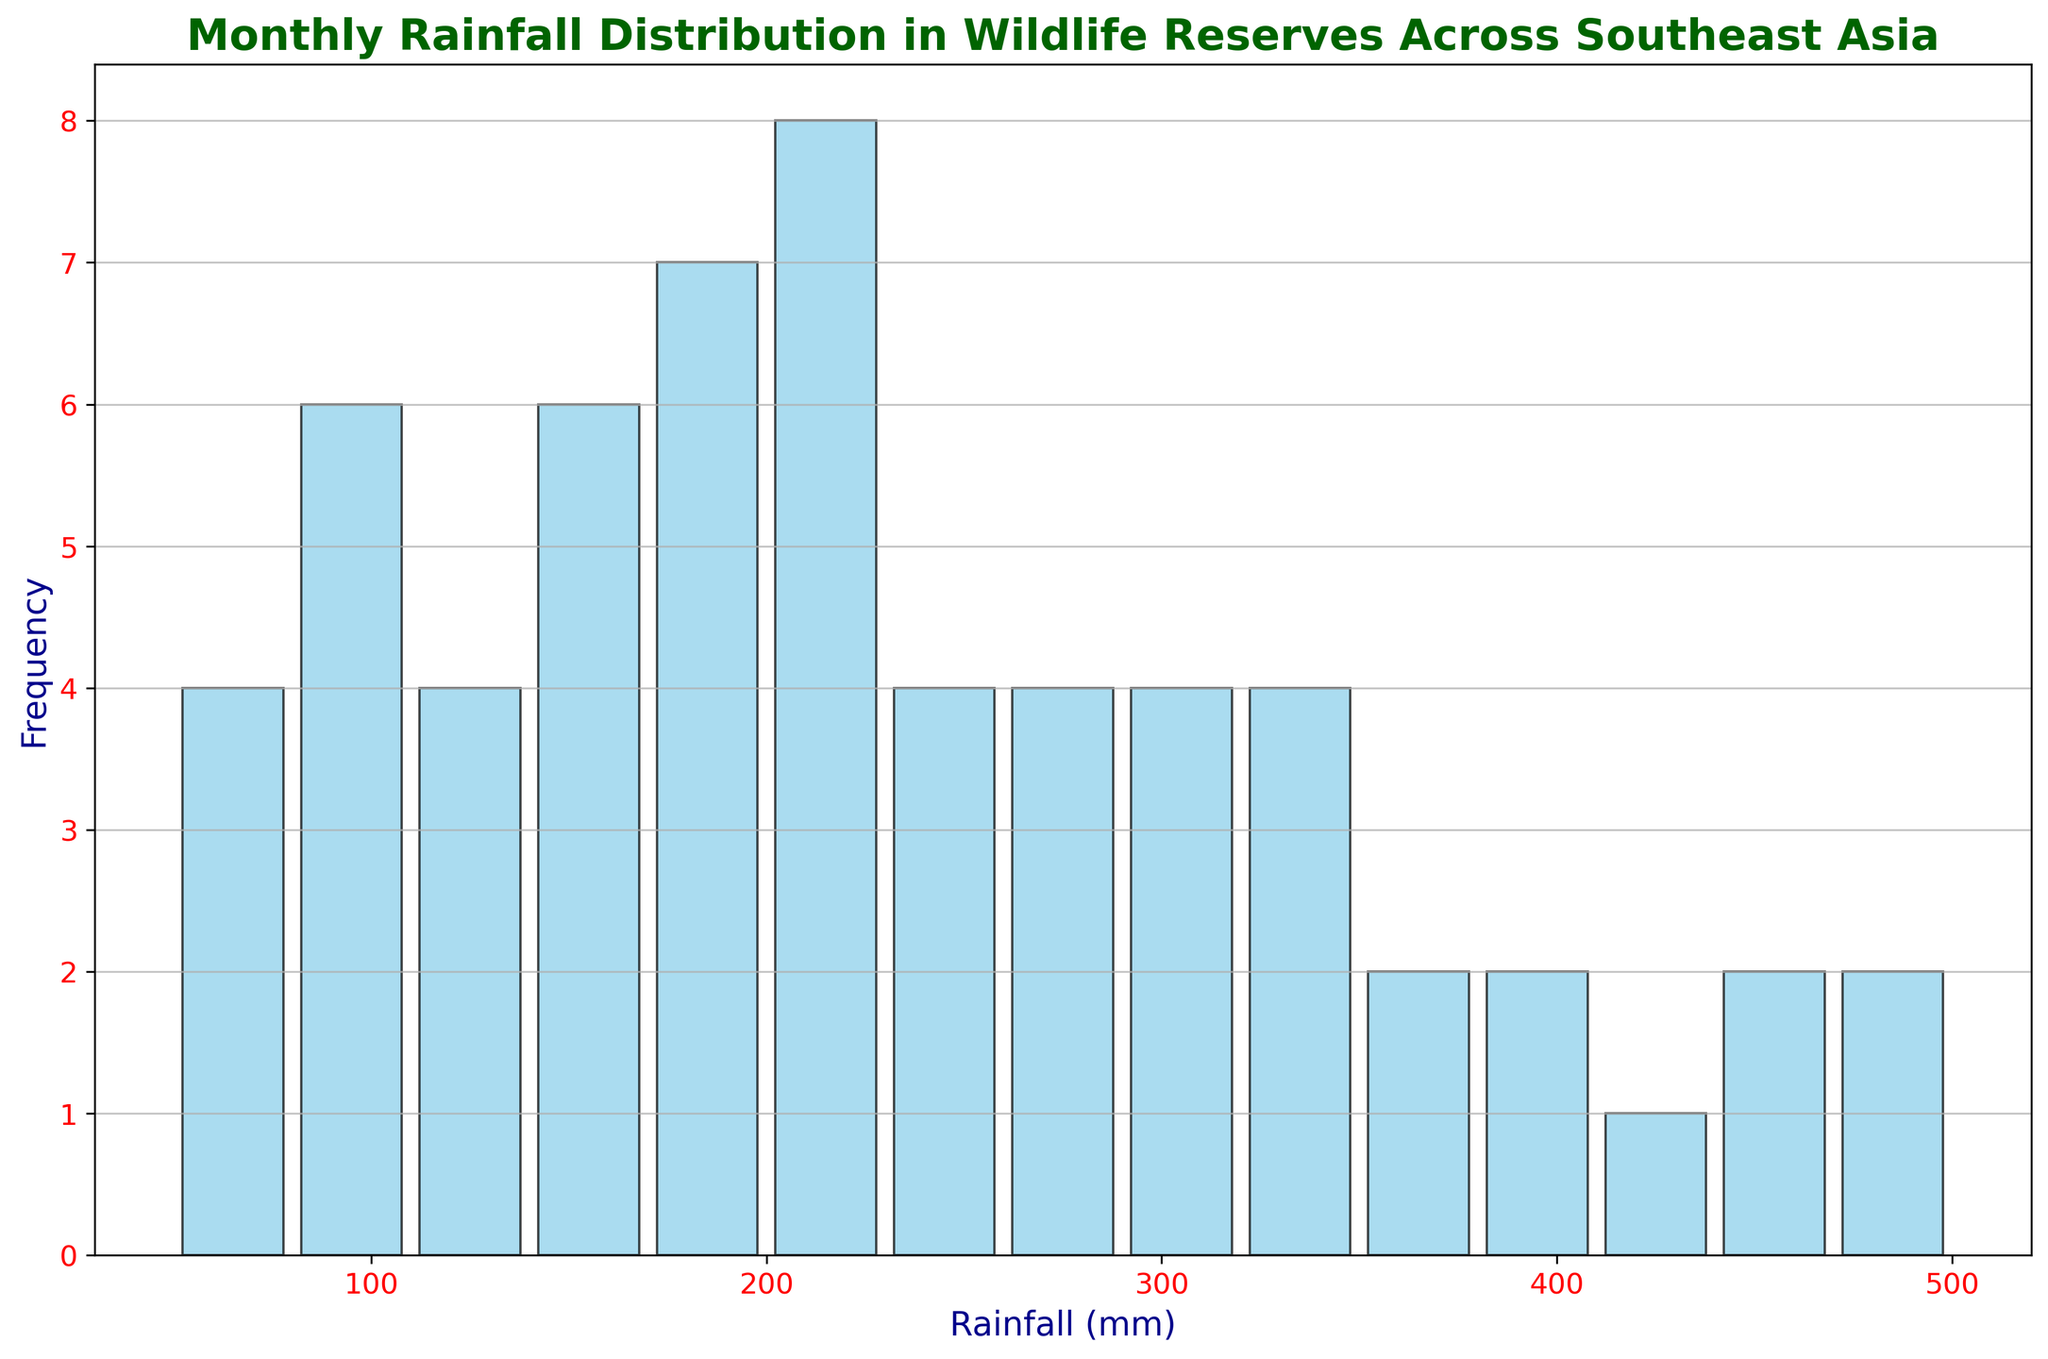What is the range of monthly rainfall observed across the wildlife reserves? The range of monthly rainfall can be determined by identifying the minimum and maximum rainfall values in the dataset. From the histogram, the smallest observed value is 50 mm, and the largest observed value is 500 mm. The range is the difference between the maximum and minimum values. Range = 500 mm - 50 mm.
Answer: 450 mm How many months experienced a rainfall between 100 mm and 200 mm? To answer this question, we need to look at the bars in the histogram that fall between 100 mm and 200 mm. By counting the frequency of these bins, we can find the total number of months. Let's assume the histogram reveals this: There are 2 bars (bins), each representing a different number of months (frequencies) within this range. Let's hypothetically say one bar represents 15 months, and another represents 5 months. Total months = 15 + 5.
Answer: 20 Which rainfall range has the highest frequency? To determine which rainfall range has the highest frequency, observe the tallest bar in the histogram. The range along the x-axis that aligns with this bar represents the rainfall range with the highest frequency. Suppose it is between 300 mm and 400 mm.
Answer: 300 mm - 400 mm How many reserves experienced more than 400 mm of rainfall? To answer this, look at the bars representing rainfall above 400 mm. By counting the frequency of these bins, we can determine the number of months (and indirectly reserves, assuming one record per month per reserve) in which more than 400 mm of rainfall was experienced. Hypothetically, if there's one bar showing frequency 3 for rainfall above 400 mm, then
Answer: 3 Which wildlife reserve had the highest recorded monthly rainfall and in which month? From the dataset, we can see monthly rainfall data for several reserves. The highest monthly rainfall is 500 mm in Khao Sok during September, as per the dataset.
Answer: Khao Sok, September 